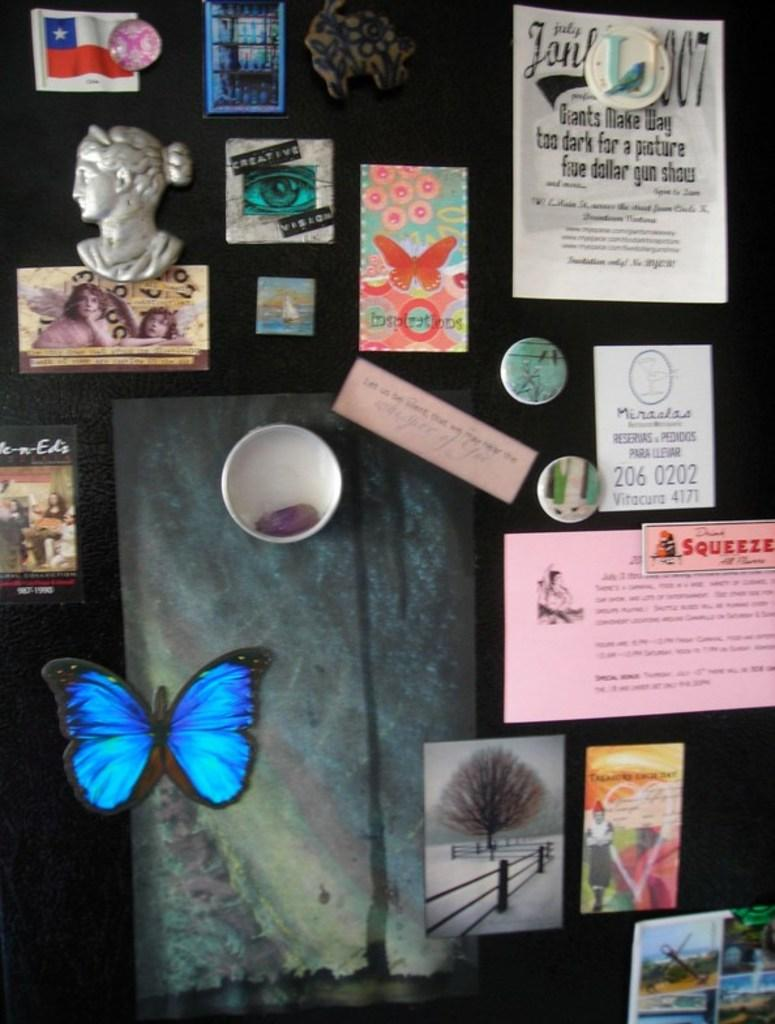What type of objects can be seen on the walls in the image? There are posters in the image. What other objects are present in the image besides the posters? There are boards and a sculpture visible in the image. Are there any living creatures depicted in the image? Yes, there is an artificial butterfly in the image. What can be read or seen in written form in the image? There is text visible in the image. What type of scarf is the weather wearing in the image? There is no weather or scarf present in the image. What type of print can be seen on the butterfly's wings in the image? The artificial butterfly in the image does not have a print on its wings, as it is not a real butterfly. 